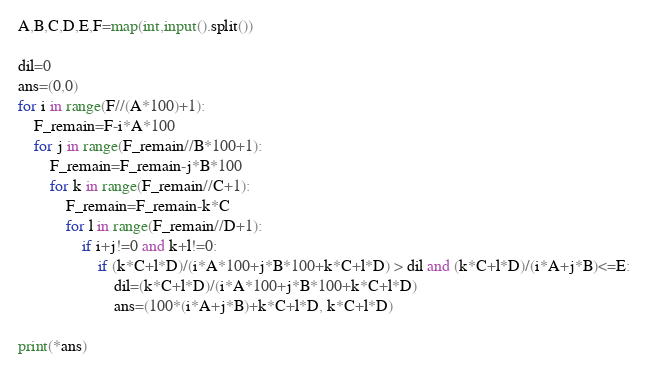<code> <loc_0><loc_0><loc_500><loc_500><_Python_>A,B,C,D,E,F=map(int,input().split())

dil=0
ans=(0,0)
for i in range(F//(A*100)+1):
    F_remain=F-i*A*100
    for j in range(F_remain//B*100+1):
        F_remain=F_remain-j*B*100   
        for k in range(F_remain//C+1):
            F_remain=F_remain-k*C
            for l in range(F_remain//D+1):
                if i+j!=0 and k+l!=0:
                    if (k*C+l*D)/(i*A*100+j*B*100+k*C+l*D) > dil and (k*C+l*D)/(i*A+j*B)<=E:
                        dil=(k*C+l*D)/(i*A*100+j*B*100+k*C+l*D)
                        ans=(100*(i*A+j*B)+k*C+l*D, k*C+l*D)

print(*ans)</code> 